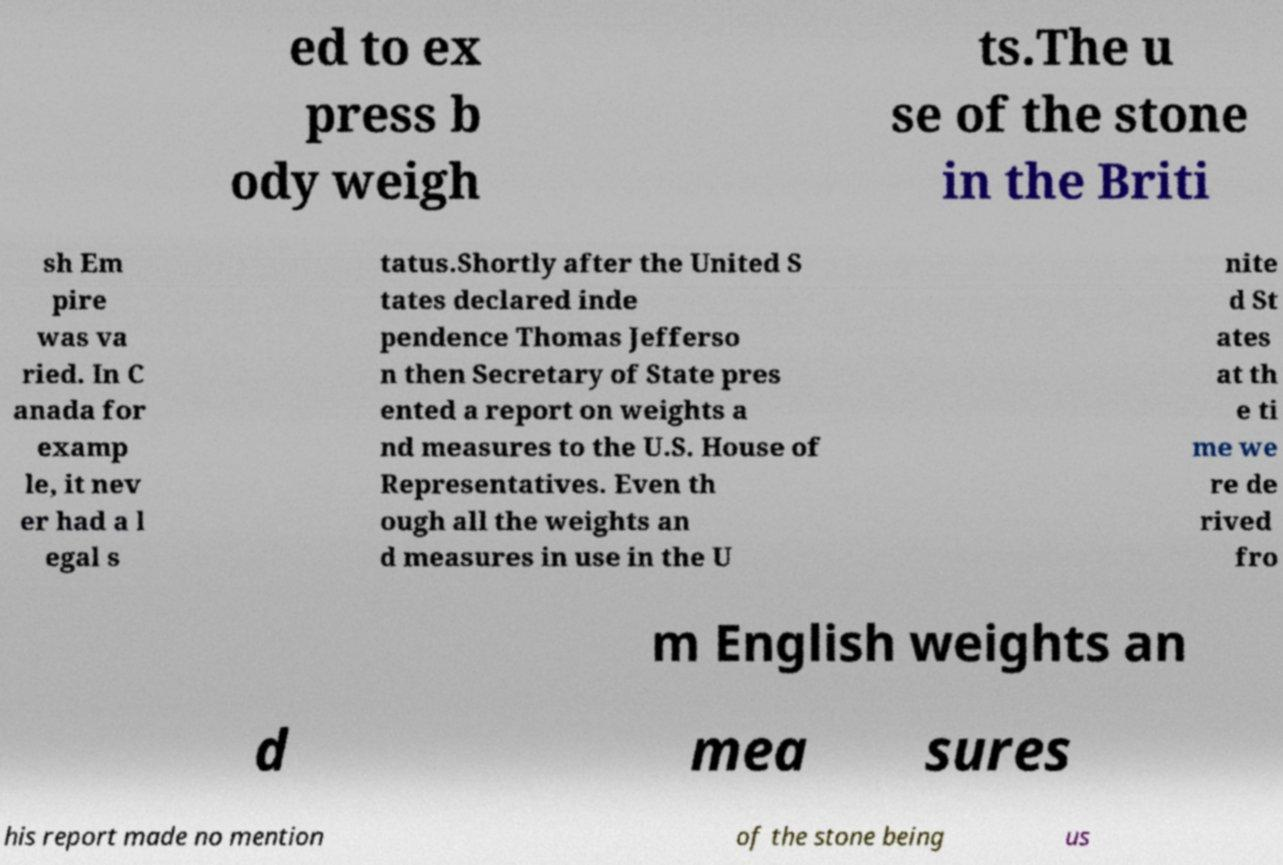Please read and relay the text visible in this image. What does it say? ed to ex press b ody weigh ts.The u se of the stone in the Briti sh Em pire was va ried. In C anada for examp le, it nev er had a l egal s tatus.Shortly after the United S tates declared inde pendence Thomas Jefferso n then Secretary of State pres ented a report on weights a nd measures to the U.S. House of Representatives. Even th ough all the weights an d measures in use in the U nite d St ates at th e ti me we re de rived fro m English weights an d mea sures his report made no mention of the stone being us 